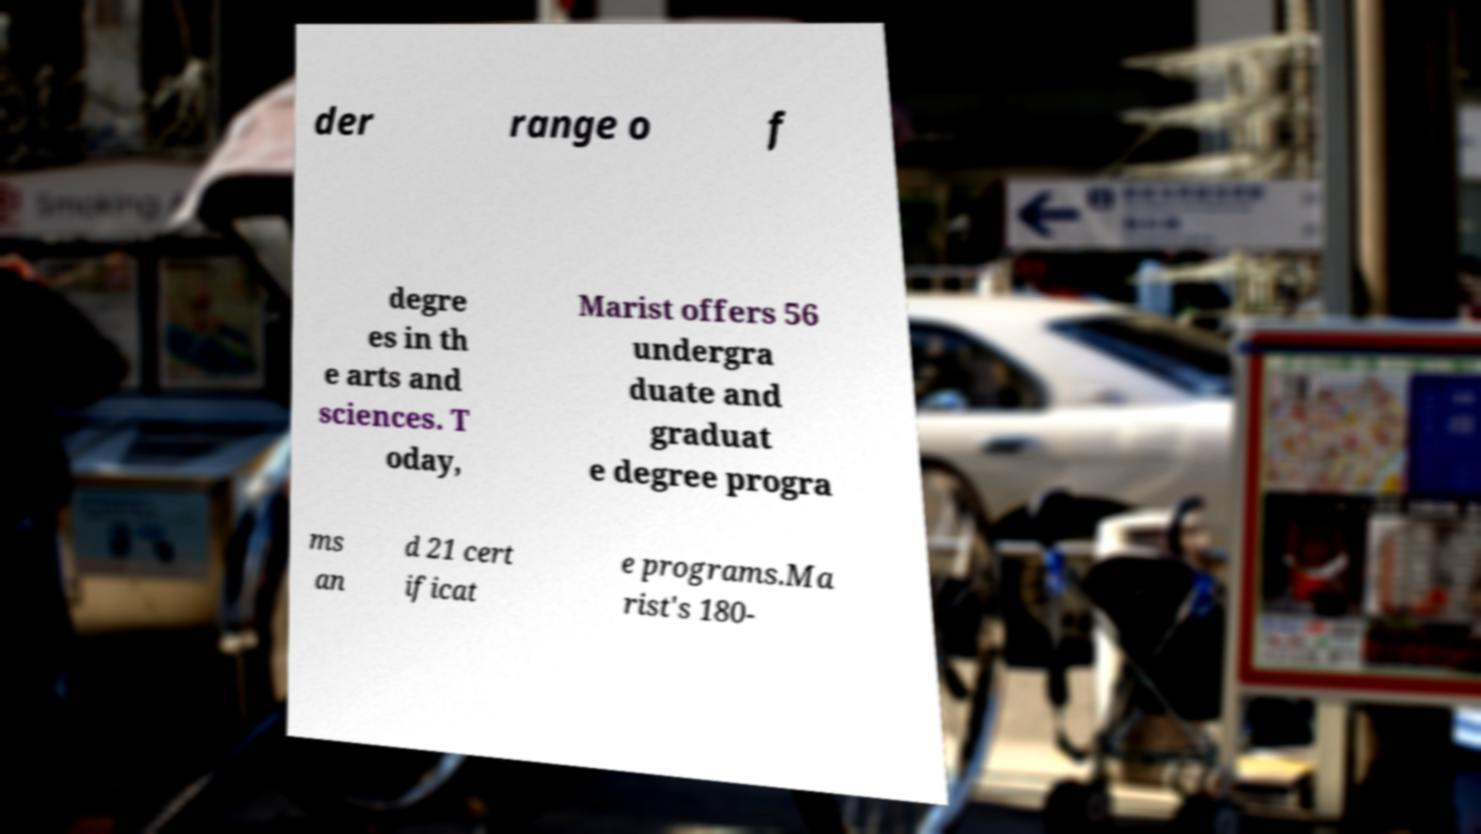Please identify and transcribe the text found in this image. der range o f degre es in th e arts and sciences. T oday, Marist offers 56 undergra duate and graduat e degree progra ms an d 21 cert ificat e programs.Ma rist's 180- 